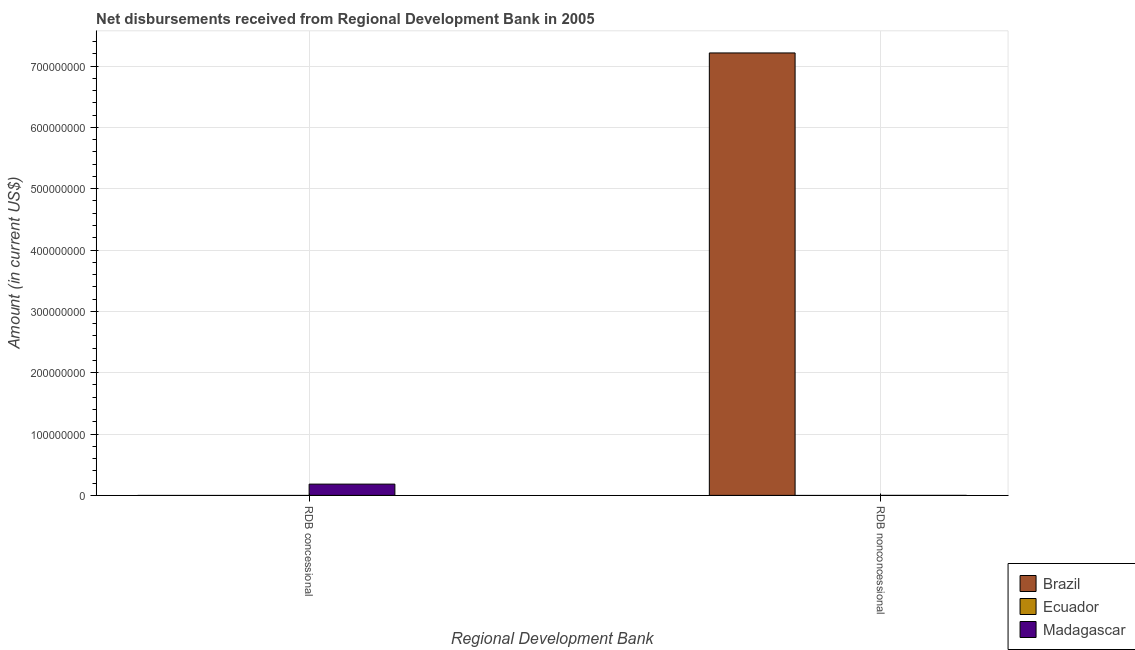How many different coloured bars are there?
Offer a terse response. 2. Are the number of bars per tick equal to the number of legend labels?
Your answer should be very brief. No. Are the number of bars on each tick of the X-axis equal?
Provide a succinct answer. Yes. How many bars are there on the 2nd tick from the left?
Your answer should be very brief. 1. What is the label of the 1st group of bars from the left?
Your answer should be compact. RDB concessional. What is the net non concessional disbursements from rdb in Brazil?
Make the answer very short. 7.21e+08. Across all countries, what is the maximum net concessional disbursements from rdb?
Ensure brevity in your answer.  1.84e+07. Across all countries, what is the minimum net non concessional disbursements from rdb?
Keep it short and to the point. 0. In which country was the net concessional disbursements from rdb maximum?
Keep it short and to the point. Madagascar. What is the total net non concessional disbursements from rdb in the graph?
Your answer should be very brief. 7.21e+08. What is the difference between the net non concessional disbursements from rdb in Madagascar and the net concessional disbursements from rdb in Ecuador?
Make the answer very short. 0. What is the average net concessional disbursements from rdb per country?
Your answer should be very brief. 6.12e+06. In how many countries, is the net non concessional disbursements from rdb greater than 520000000 US$?
Ensure brevity in your answer.  1. In how many countries, is the net non concessional disbursements from rdb greater than the average net non concessional disbursements from rdb taken over all countries?
Make the answer very short. 1. How many bars are there?
Provide a short and direct response. 2. Are all the bars in the graph horizontal?
Your answer should be compact. No. What is the difference between two consecutive major ticks on the Y-axis?
Your response must be concise. 1.00e+08. Are the values on the major ticks of Y-axis written in scientific E-notation?
Offer a very short reply. No. Does the graph contain grids?
Make the answer very short. Yes. Where does the legend appear in the graph?
Ensure brevity in your answer.  Bottom right. How many legend labels are there?
Keep it short and to the point. 3. What is the title of the graph?
Offer a terse response. Net disbursements received from Regional Development Bank in 2005. Does "Sint Maarten (Dutch part)" appear as one of the legend labels in the graph?
Your response must be concise. No. What is the label or title of the X-axis?
Your answer should be compact. Regional Development Bank. What is the label or title of the Y-axis?
Your answer should be very brief. Amount (in current US$). What is the Amount (in current US$) in Brazil in RDB concessional?
Offer a terse response. 0. What is the Amount (in current US$) of Madagascar in RDB concessional?
Ensure brevity in your answer.  1.84e+07. What is the Amount (in current US$) in Brazil in RDB nonconcessional?
Your response must be concise. 7.21e+08. What is the Amount (in current US$) in Madagascar in RDB nonconcessional?
Your answer should be very brief. 0. Across all Regional Development Bank, what is the maximum Amount (in current US$) in Brazil?
Your answer should be compact. 7.21e+08. Across all Regional Development Bank, what is the maximum Amount (in current US$) in Madagascar?
Offer a very short reply. 1.84e+07. Across all Regional Development Bank, what is the minimum Amount (in current US$) of Brazil?
Make the answer very short. 0. What is the total Amount (in current US$) of Brazil in the graph?
Make the answer very short. 7.21e+08. What is the total Amount (in current US$) in Madagascar in the graph?
Your answer should be very brief. 1.84e+07. What is the average Amount (in current US$) in Brazil per Regional Development Bank?
Offer a terse response. 3.61e+08. What is the average Amount (in current US$) of Madagascar per Regional Development Bank?
Provide a succinct answer. 9.18e+06. What is the difference between the highest and the lowest Amount (in current US$) in Brazil?
Make the answer very short. 7.21e+08. What is the difference between the highest and the lowest Amount (in current US$) in Madagascar?
Make the answer very short. 1.84e+07. 